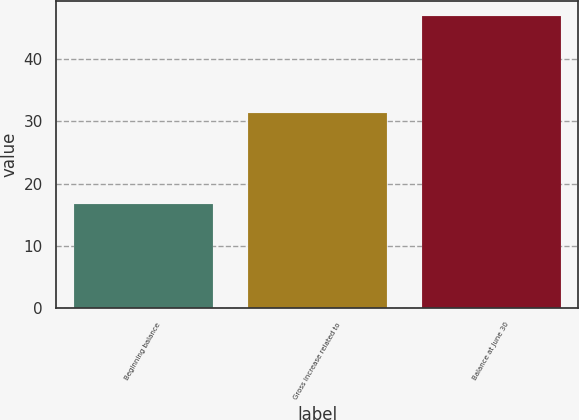Convert chart to OTSL. <chart><loc_0><loc_0><loc_500><loc_500><bar_chart><fcel>Beginning balance<fcel>Gross increase related to<fcel>Balance at June 30<nl><fcel>16.7<fcel>31.4<fcel>47<nl></chart> 